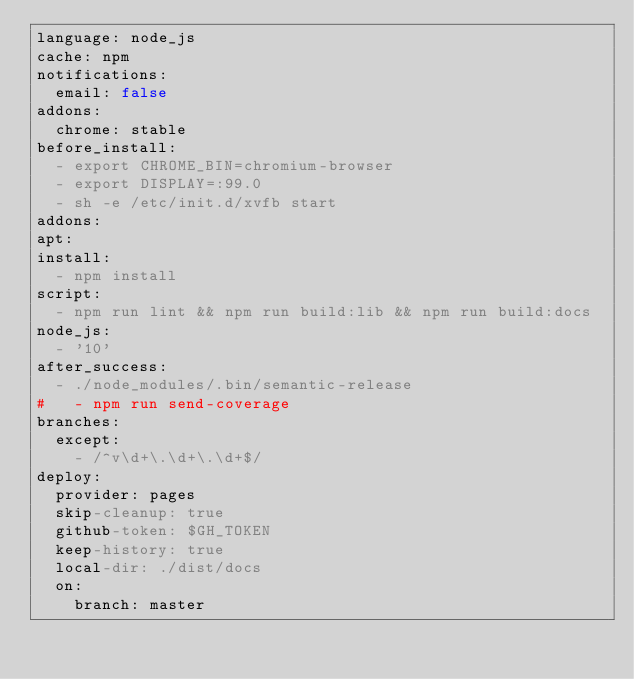<code> <loc_0><loc_0><loc_500><loc_500><_YAML_>language: node_js
cache: npm
notifications:
  email: false
addons:
  chrome: stable
before_install:
  - export CHROME_BIN=chromium-browser
  - export DISPLAY=:99.0
  - sh -e /etc/init.d/xvfb start
addons:
apt:
install:
  - npm install
script:
  - npm run lint && npm run build:lib && npm run build:docs
node_js:
  - '10'
after_success:
  - ./node_modules/.bin/semantic-release
#   - npm run send-coverage
branches:
  except:
    - /^v\d+\.\d+\.\d+$/
deploy:
  provider: pages
  skip-cleanup: true
  github-token: $GH_TOKEN
  keep-history: true
  local-dir: ./dist/docs
  on:
    branch: master
</code> 